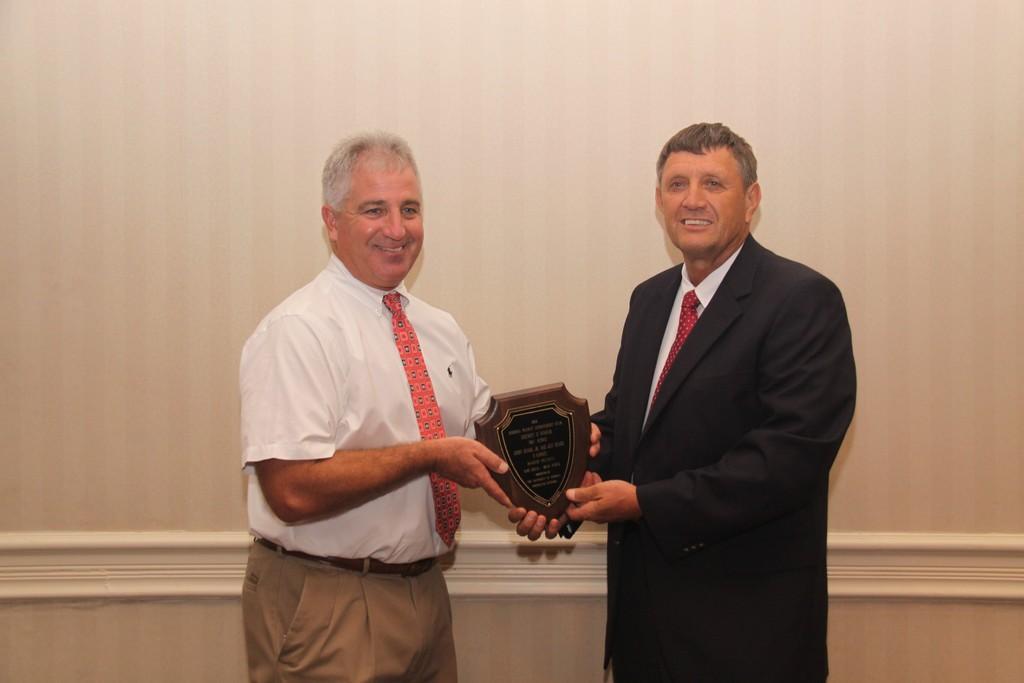Could you give a brief overview of what you see in this image? In this picture we can see two men and they are holding a shield and in the background we can see the wall. 